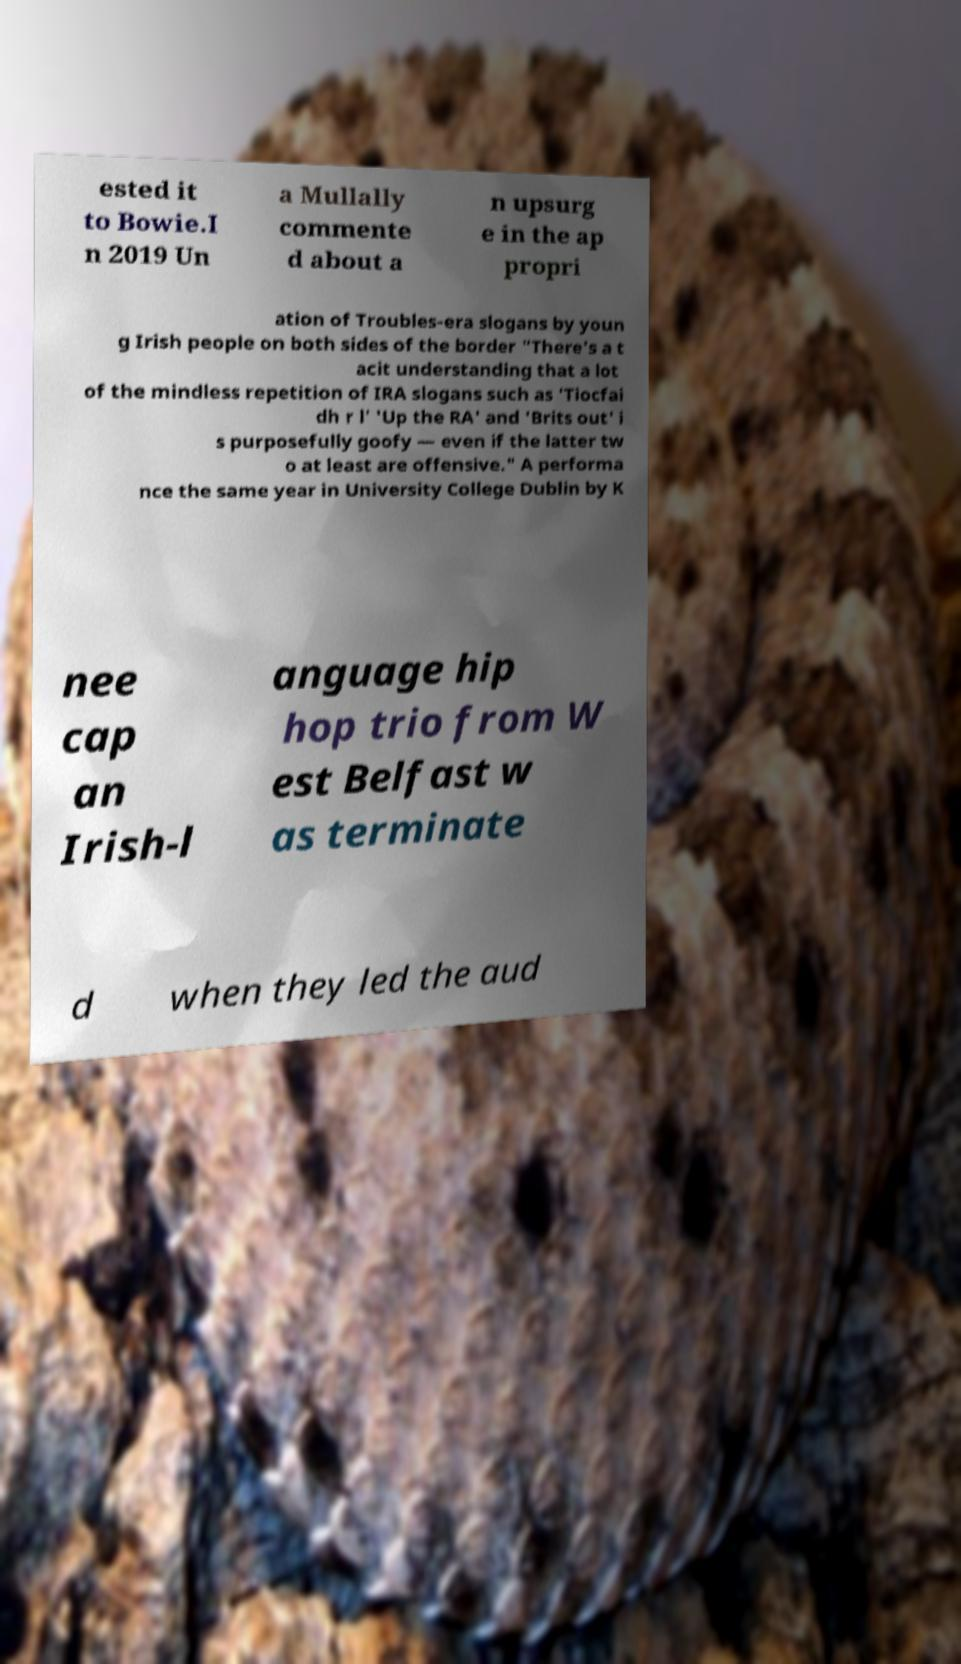Can you read and provide the text displayed in the image?This photo seems to have some interesting text. Can you extract and type it out for me? ested it to Bowie.I n 2019 Un a Mullally commente d about a n upsurg e in the ap propri ation of Troubles-era slogans by youn g Irish people on both sides of the border "There's a t acit understanding that a lot of the mindless repetition of IRA slogans such as 'Tiocfai dh r l' 'Up the RA' and 'Brits out' i s purposefully goofy — even if the latter tw o at least are offensive." A performa nce the same year in University College Dublin by K nee cap an Irish-l anguage hip hop trio from W est Belfast w as terminate d when they led the aud 